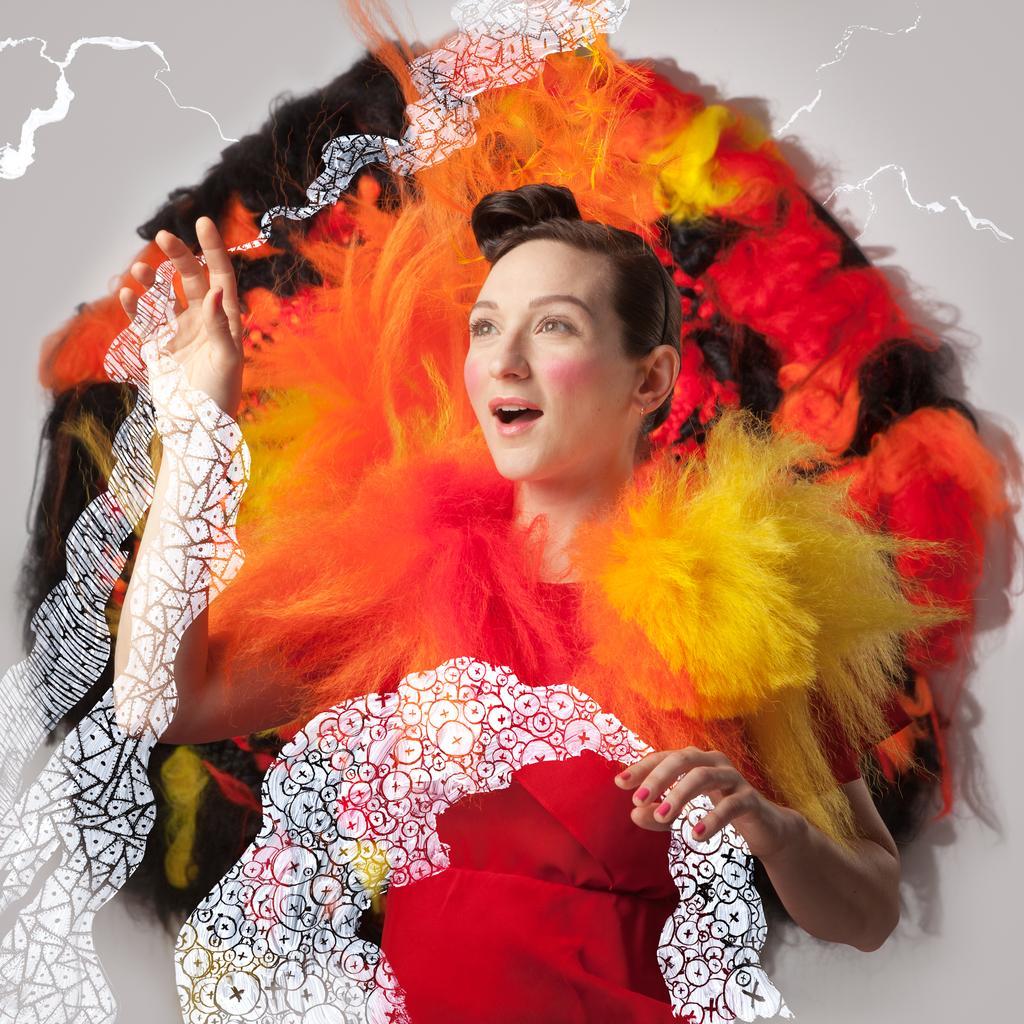In one or two sentences, can you explain what this image depicts? In this image we can see a lady standing. She is wearing a costume. 